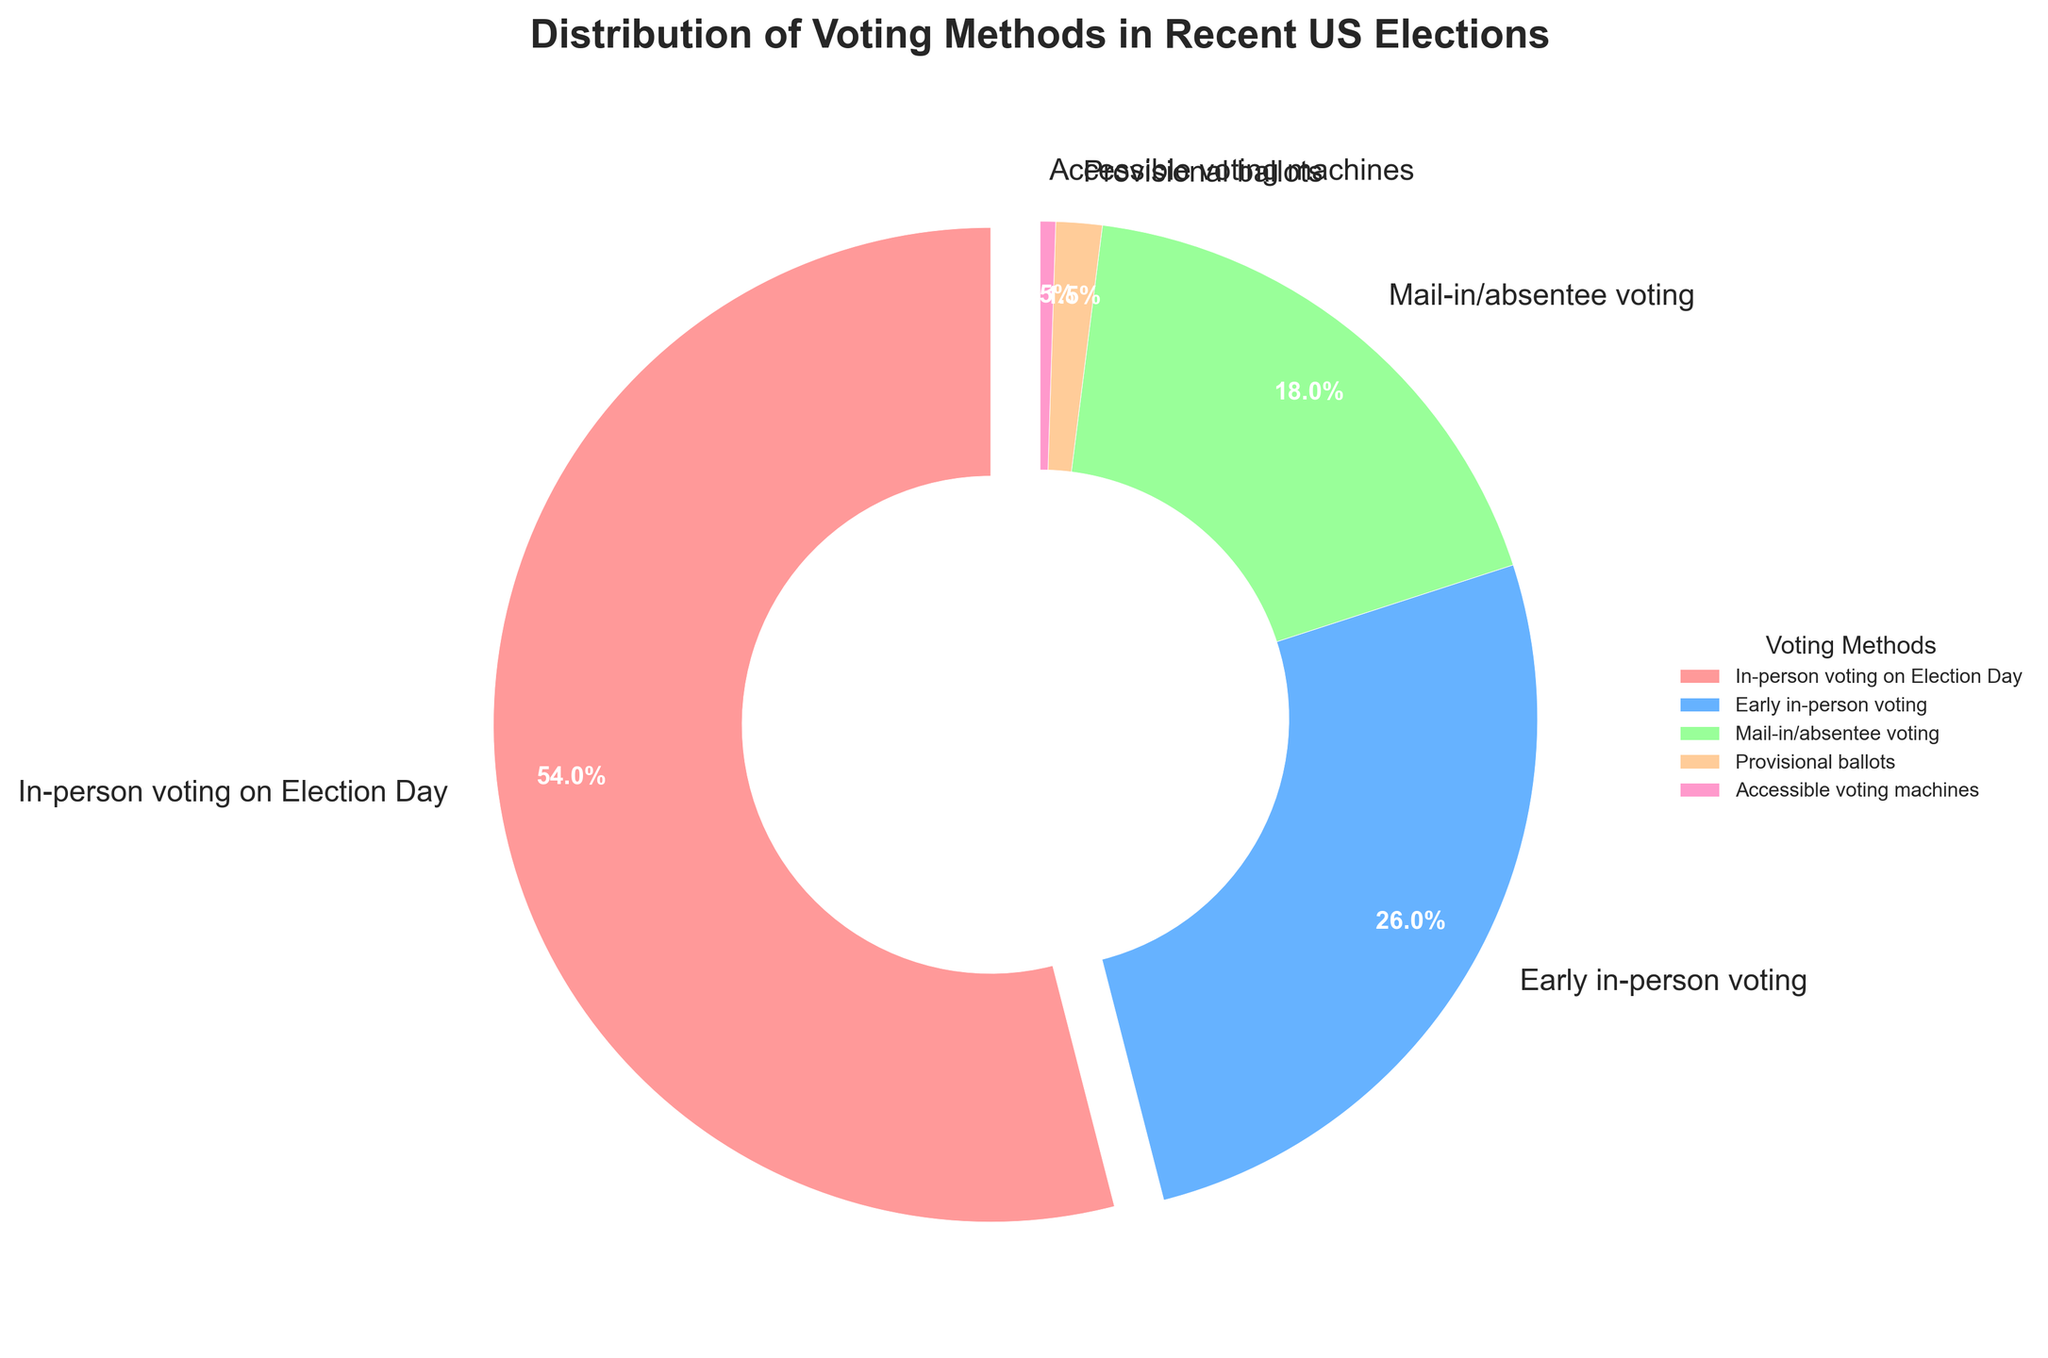What is the percentage of people who voted in person on Election Day? The section of the pie chart labeled "In-person voting on Election Day" indicates 54%. Since we are asked for the percentage, we simply read the figure.
Answer: 54% Which voting method is used the least, and what percentage does it represent? The pie chart shows "Accessible voting machines" as the smallest section, representing 0.5%. This is deduced by comparing all segments and identifying the smallest one.
Answer: Accessible voting machines, 0.5% What is the combined percentage of early in-person voting and mail-in/absentee voting? The pie chart provides 26% for early in-person voting and 18% for mail-in/absentee voting. Adding these percentages together gives 26 + 18 = 44%.
Answer: 44% Compare the percentages of in-person voting on Election Day and early in-person voting. Which is higher and by how much? The pie chart shows 54% for in-person voting on Election Day and 26% for early in-person voting. The difference is calculated as 54 - 26 = 28%. So, in-person voting on Election Day is higher by 28%.
Answer: In-person voting on Election Day, 28% If you combine the percentages for mail-in/absentee voting, provisional ballots, and accessible voting machines, what total do you get? According to the pie chart, the percentages are 18% for mail-in/absentee voting, 1.5% for provisional ballots, and 0.5% for accessible voting machines. Adding these gives 18 + 1.5 + 0.5 = 20%.
Answer: 20% What color represents early in-person voting in the pie chart? The pie chart segment for early in-person voting is colored blue. This is deduced by identifying the section labeled for early in-person voting and noting its color.
Answer: Blue By how much does the in-person voting on Election Day exceed the combined percentage of mail-in/absentee voting and provisional ballots? The pie chart indicates 54% for in-person voting on Election Day, and combining mail-in/absentee voting (18%) and provisional ballots (1.5%) gives 19.5%. Subtracting these two values results in 54 - 19.5 = 34.5%.
Answer: 34.5% What proportion of voters used provisional ballots? The pie chart section for provisional ballots represents 1.5%. We identify this by locating the segment labeled "Provisional ballots" and noting its percentage.
Answer: 1.5% Which two voting methods combined have a percentage closest to the percentage for in-person voting on Election Day? In-person voting on Election Day is 54%. Combining early in-person voting (26%) and mail-in/absentee voting (18%) gives 44%. Combining early in-person voting (26%) and provisional ballots (1.5%) gives 27.5%. Combinations including accessible voting machines yield even lower totals. Therefore, the closest match is early in-person voting and mail-in/absentee voting.
Answer: Early in-person voting and mail-in/absentee voting 